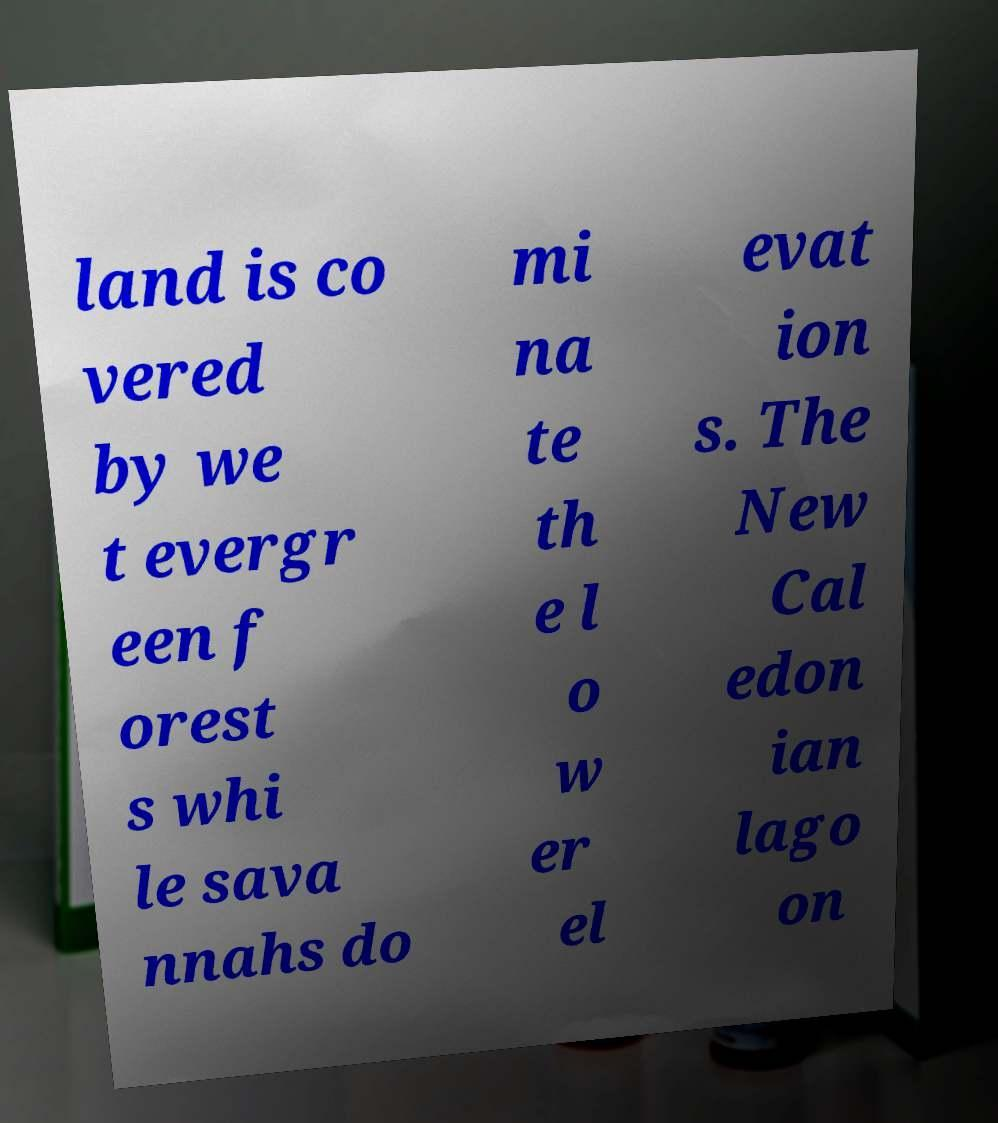Can you accurately transcribe the text from the provided image for me? land is co vered by we t evergr een f orest s whi le sava nnahs do mi na te th e l o w er el evat ion s. The New Cal edon ian lago on 